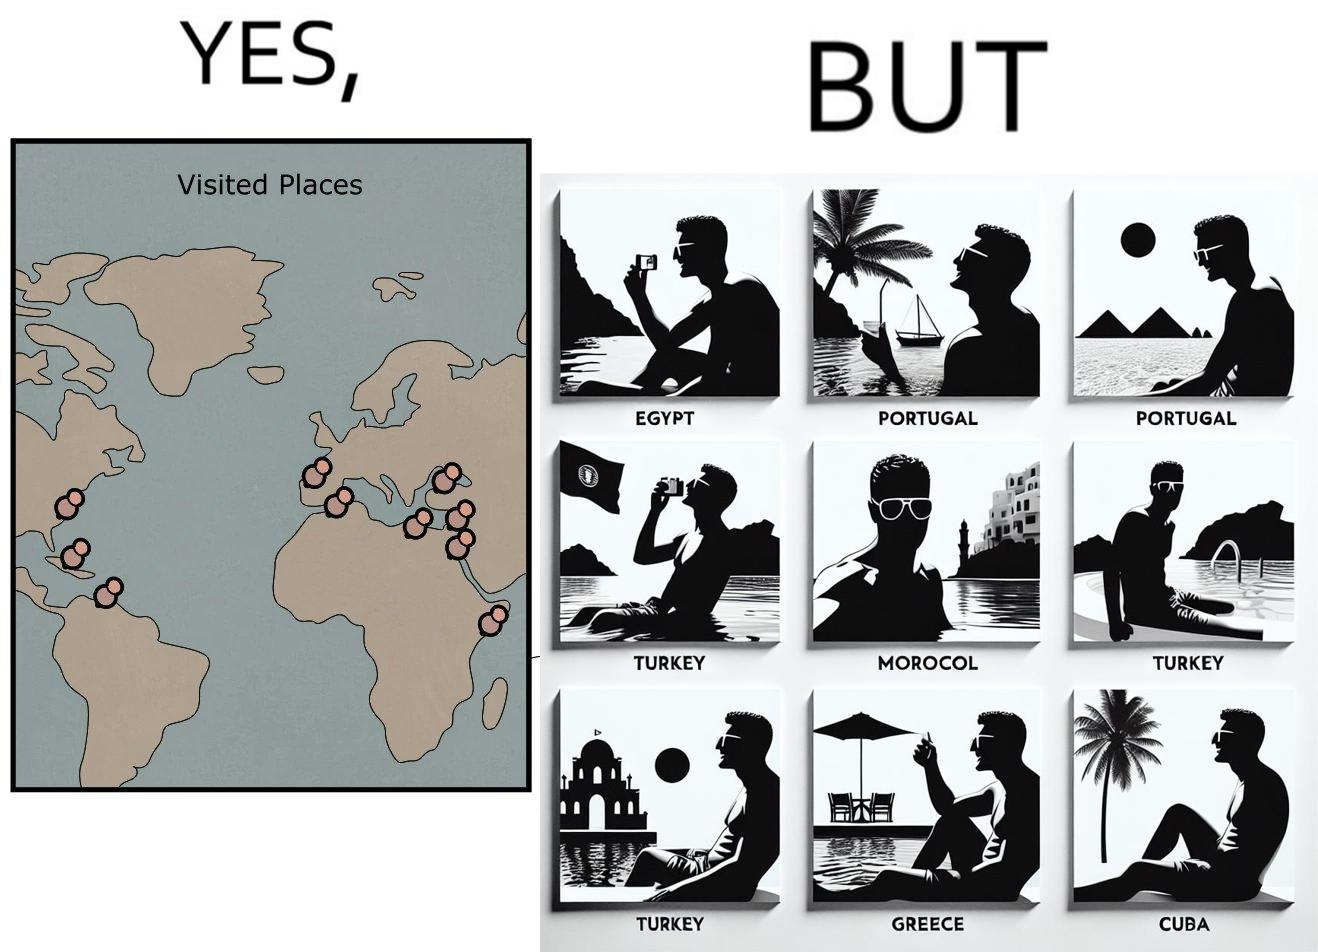Describe the satirical element in this image. The image is satirical because while the man has visited all the place marked on the map, he only seems to have swam in pools in all these differnt countries and has not actually seen these places. 